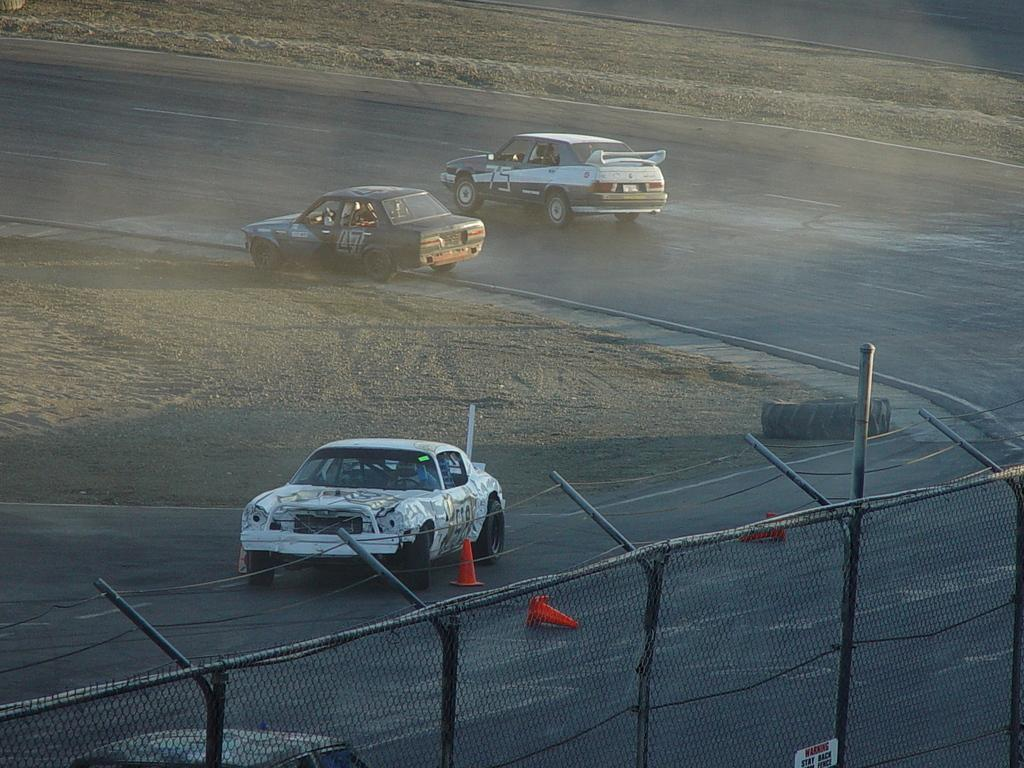What is the main feature of the image? There is a racing track in the image. What is happening on the racing track? There are cars on the racing track. Can you describe any objects near the racing track? There is a tyre on the road and iron fencing in the image. Who is the manager of the line in the image? There is no line or manager present in the image. Is there a fire visible in the image? No, there is no fire visible in the image. 